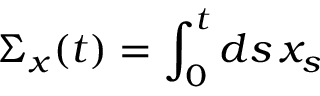Convert formula to latex. <formula><loc_0><loc_0><loc_500><loc_500>\Sigma _ { x } ( t ) = \int _ { 0 } ^ { t } d s \, x _ { s }</formula> 